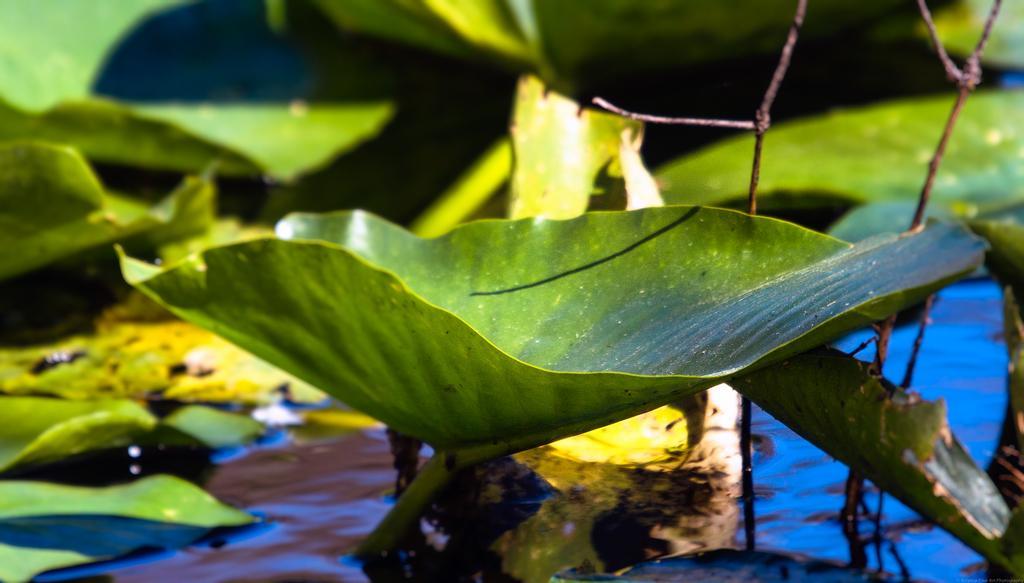Please provide a concise description of this image. In this image I can see many plants and I can also see the water. 